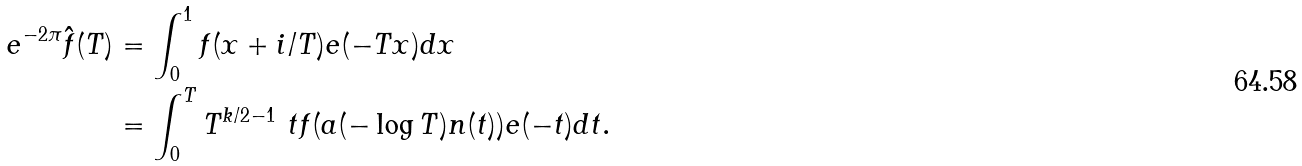Convert formula to latex. <formula><loc_0><loc_0><loc_500><loc_500>e ^ { - 2 \pi } \hat { f } ( T ) & = \int _ { 0 } ^ { 1 } f ( x + i / T ) e ( - T x ) d x \\ & = \int _ { 0 } ^ { T } T ^ { k / 2 - 1 } \ t f ( a ( - \log { T } ) n ( t ) ) e ( - t ) d t .</formula> 